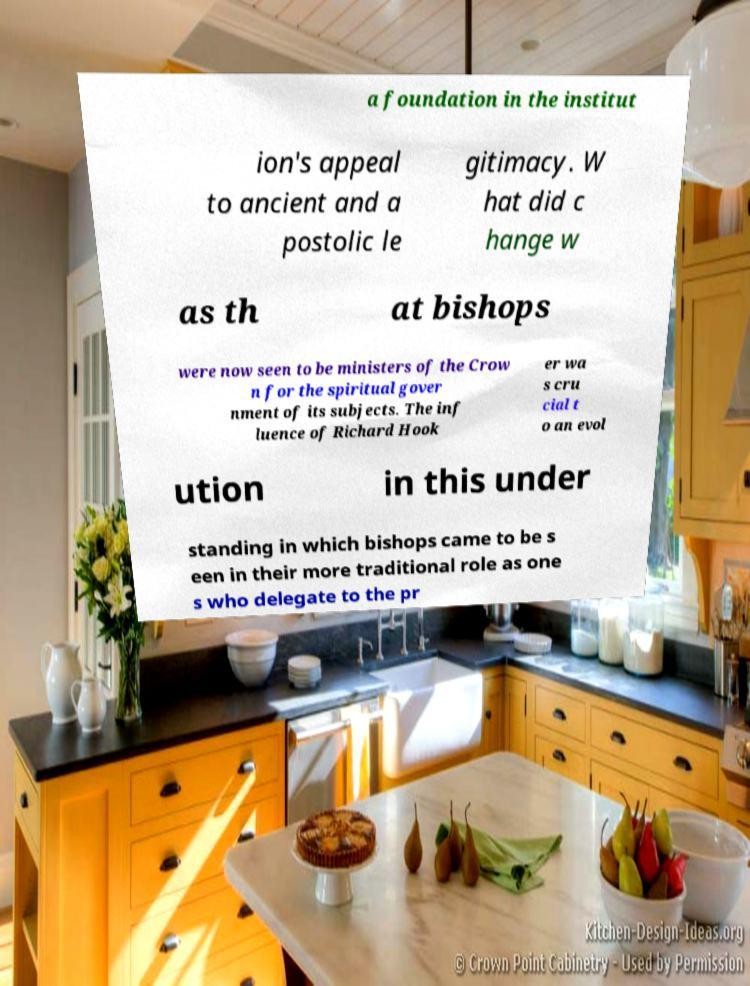There's text embedded in this image that I need extracted. Can you transcribe it verbatim? a foundation in the institut ion's appeal to ancient and a postolic le gitimacy. W hat did c hange w as th at bishops were now seen to be ministers of the Crow n for the spiritual gover nment of its subjects. The inf luence of Richard Hook er wa s cru cial t o an evol ution in this under standing in which bishops came to be s een in their more traditional role as one s who delegate to the pr 